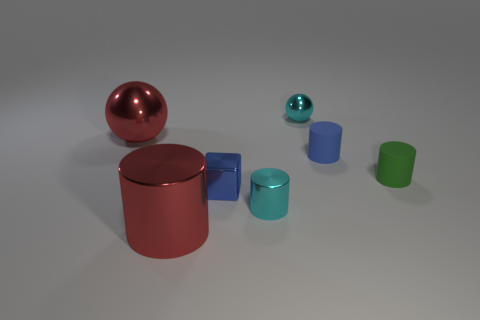What number of large objects have the same material as the cyan cylinder?
Keep it short and to the point. 2. Is the shape of the small cyan thing in front of the big metallic ball the same as  the tiny blue metallic thing?
Your answer should be compact. No. There is a small object in front of the blue block; what shape is it?
Give a very brief answer. Cylinder. What is the size of the rubber thing that is the same color as the tiny shiny cube?
Ensure brevity in your answer.  Small. What material is the large red cylinder?
Make the answer very short. Metal. What color is the metal thing that is the same size as the red sphere?
Your answer should be very brief. Red. The tiny shiny thing that is the same color as the tiny shiny ball is what shape?
Give a very brief answer. Cylinder. Is the tiny green object the same shape as the blue metal thing?
Make the answer very short. No. There is a object that is to the right of the tiny shiny cube and in front of the blue metal cube; what material is it?
Your response must be concise. Metal. How big is the shiny cube?
Make the answer very short. Small. 